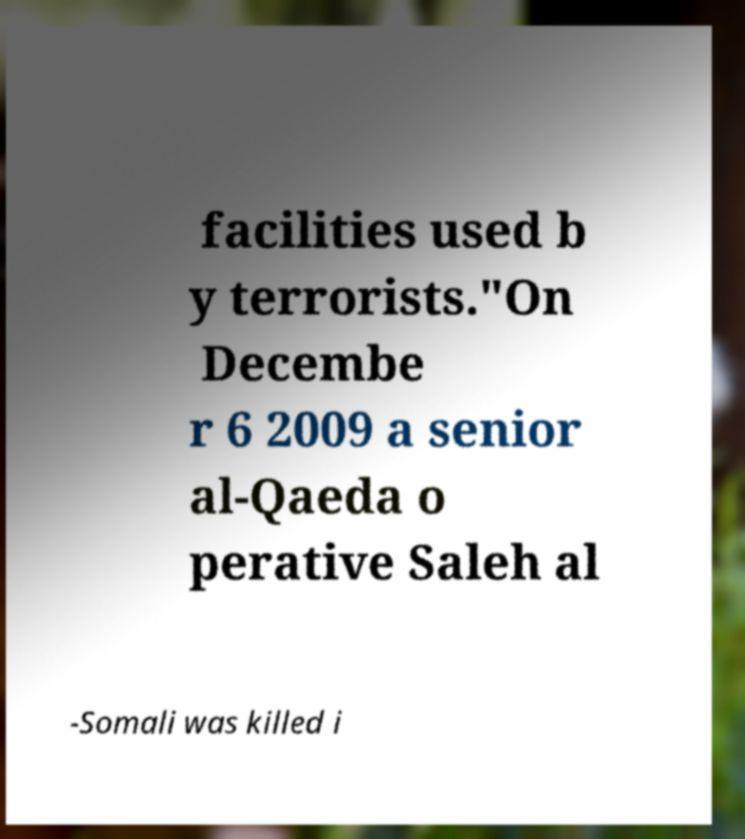Could you assist in decoding the text presented in this image and type it out clearly? facilities used b y terrorists."On Decembe r 6 2009 a senior al-Qaeda o perative Saleh al -Somali was killed i 